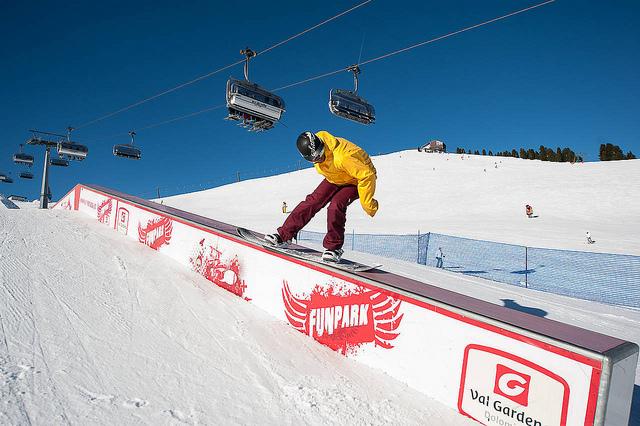What is floating above the person?
Concise answer only. Ski lift. How fast is he going?
Give a very brief answer. Fast. What color is the snow?
Concise answer only. White. 